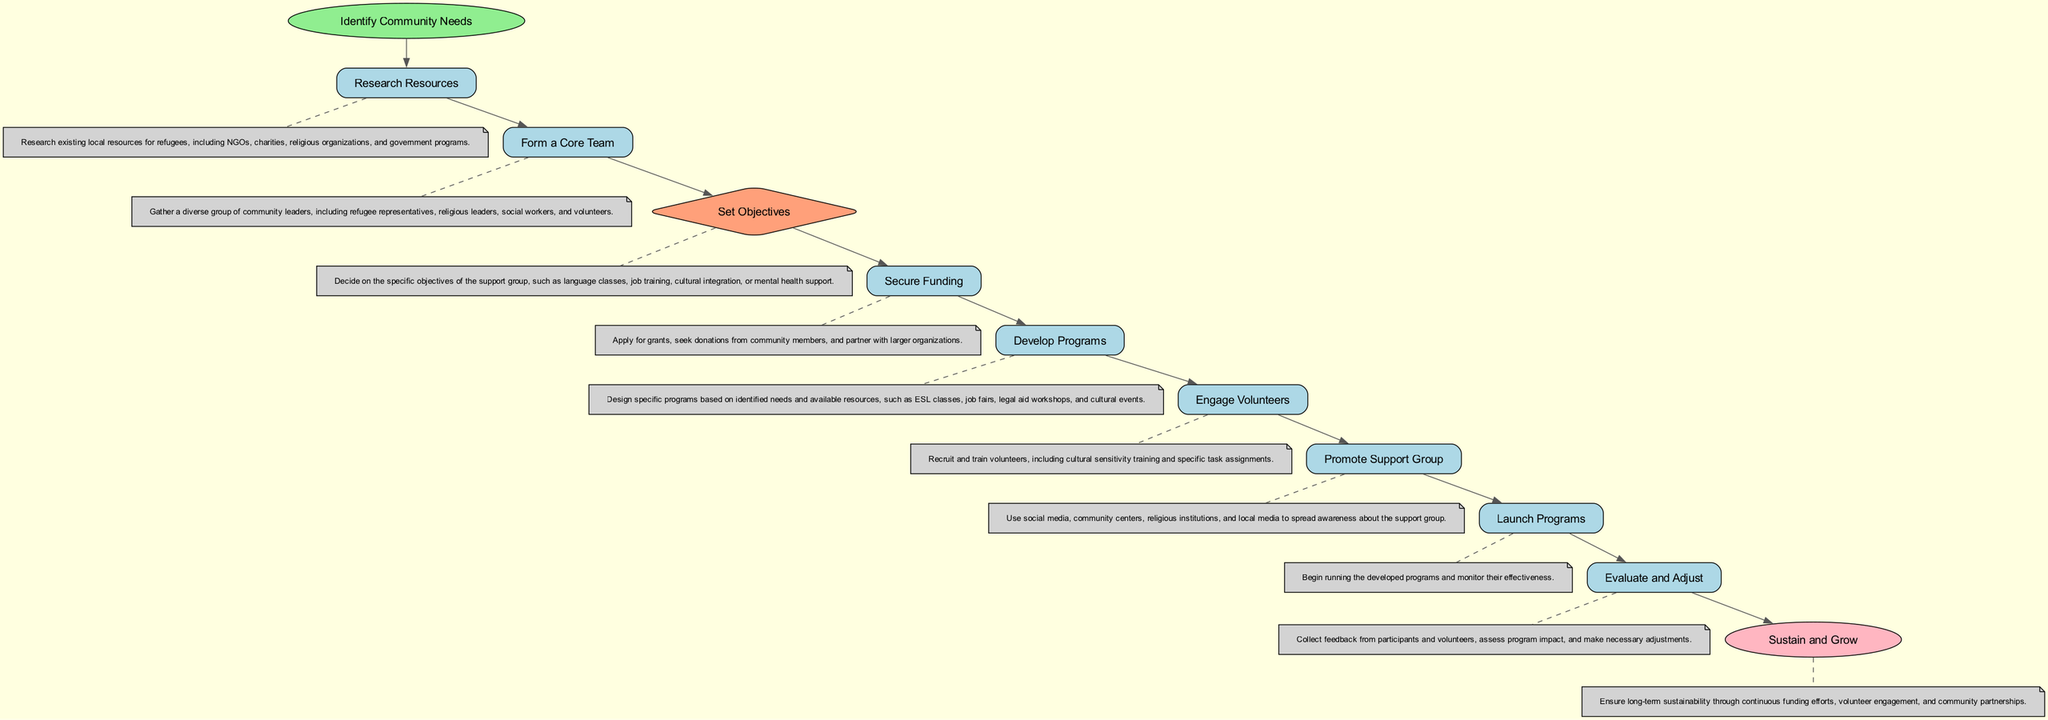What is the first step in setting up the support group? The diagram starts with the node "Identify Community Needs," indicating that this is the initial step in the process.
Answer: Identify Community Needs How many nodes are in the flowchart? Counting the individual elements in the diagram provides a total of ten nodes representing different steps in the process of setting up a support group.
Answer: Ten What is the last step of the flowchart? According to the diagram, the last step is "Sustain and Grow," which signifies the conclusion of the process focused on maintaining the group.
Answer: Sustain and Grow What type of node is "Set Objectives"? "Set Objectives" is classified as a decision node in the diagram, indicated by its diamond shape.
Answer: Decision Which step involves applying for grants? The "Secure Funding" step specifically mentions applying for grants, indicating its purpose within the flowchart.
Answer: Secure Funding After forming a core team, which step follows? The flowchart flows from "Form a Core Team" directly to the step "Set Objectives," indicating that setting objectives comes next.
Answer: Set Objectives Which step emphasizes the engagement of volunteers? "Engage Volunteers" explicitly refers to the recruitment and training of volunteers, highlighting its focus in the diagram.
Answer: Engage Volunteers What information is provided for the "Develop Programs" step? "Develop Programs" is described as designing specific programs based on identified needs and available resources, detailing its purpose in the flowchart.
Answer: Design specific programs How does the evaluation of the programs occur in the flowchart? The "Evaluate and Adjust" step involves collecting feedback from participants and volunteers to assess program impact and make necessary adjustments.
Answer: Collect feedback What color represents the "end" node in the flowchart? The end node, "Sustain and Grow," is colored light pink in the diagram, distinguishing it as the final step.
Answer: Light pink 